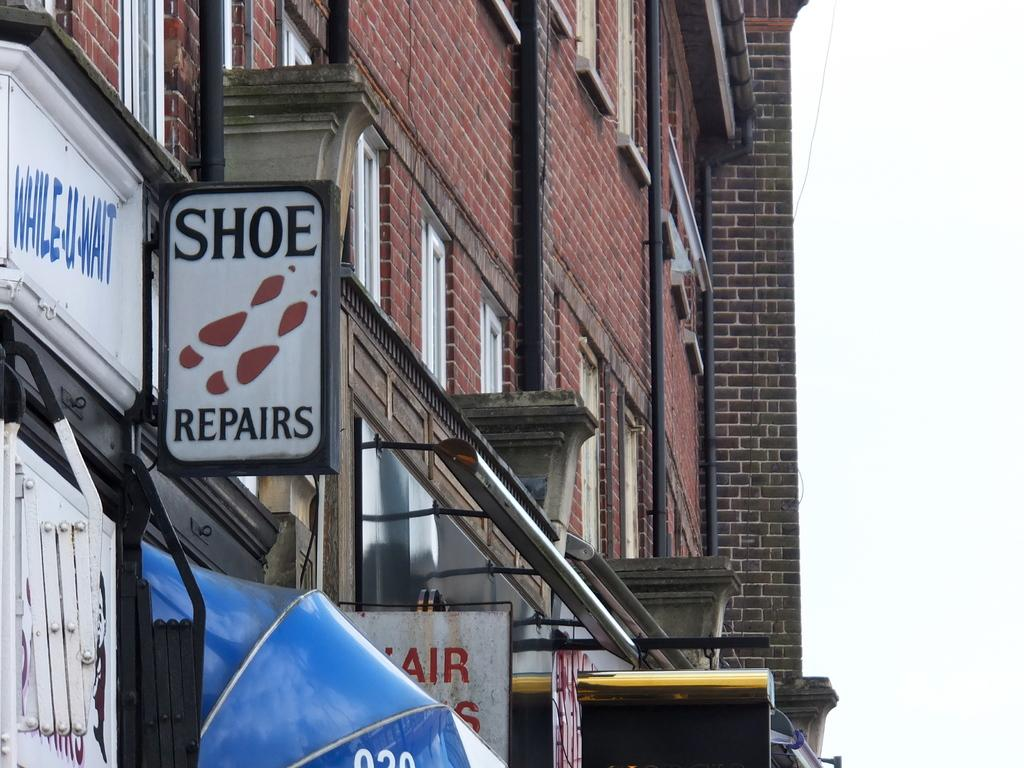What is the main structure visible in the image? There is a building in the image. What feature can be seen on the building? The building has windows. What else is present on the building besides windows? There are boards with text on the building. What type of behavior can be observed in the cat in the image? There is no cat present in the image, so no behavior can be observed. 